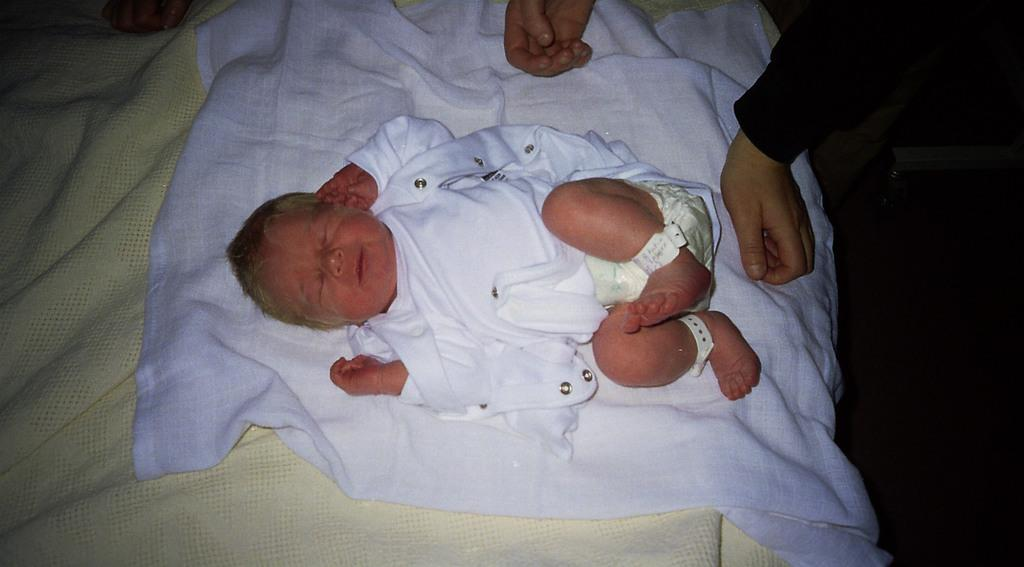What is the main subject of the image? The main subject of the image is a kid. Where is the kid located in the image? The kid is on a white cloth. Whose hands are visible in the image? The hands of a person are visible in the image. What type of ink is being used by the goat in the image? There is no goat present in the image, and therefore no ink or ink-related activity can be observed. 